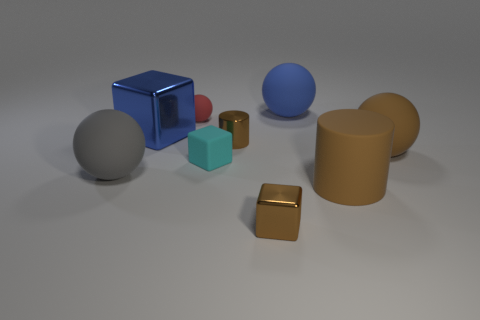The other small sphere that is made of the same material as the blue ball is what color?
Give a very brief answer. Red. Is the small cyan thing the same shape as the blue matte object?
Ensure brevity in your answer.  No. What number of balls are to the left of the brown rubber cylinder and in front of the big blue rubber ball?
Provide a short and direct response. 2. What number of metal objects are either brown cylinders or blocks?
Make the answer very short. 3. There is a blue thing behind the big blue thing in front of the red object; what size is it?
Keep it short and to the point. Large. There is a ball that is the same color as the rubber cylinder; what is it made of?
Your answer should be compact. Rubber. Is there a ball to the left of the tiny shiny thing that is behind the tiny brown thing that is in front of the big cylinder?
Offer a terse response. Yes. Do the big sphere that is left of the small red matte ball and the brown cylinder on the right side of the large blue matte thing have the same material?
Your response must be concise. Yes. What number of objects are yellow cylinders or objects that are right of the gray matte sphere?
Offer a very short reply. 8. What number of big cyan objects are the same shape as the small cyan matte thing?
Offer a terse response. 0. 